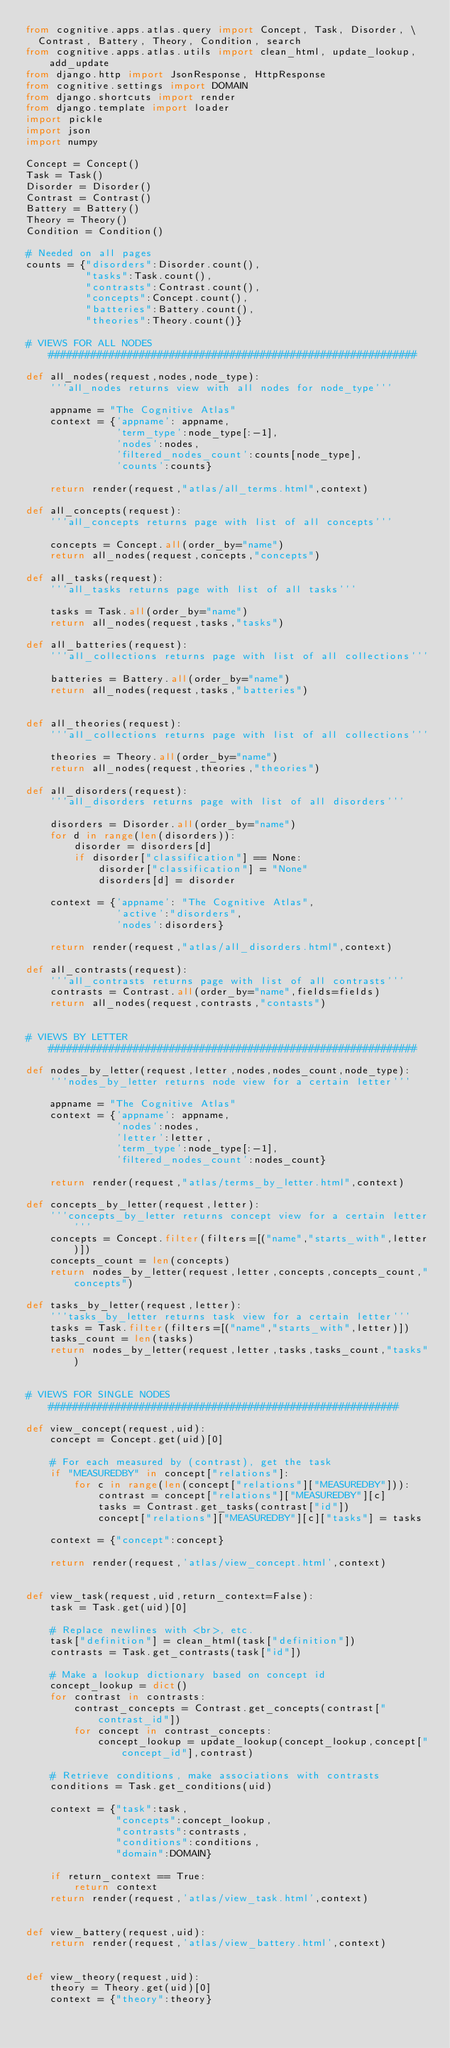Convert code to text. <code><loc_0><loc_0><loc_500><loc_500><_Python_>from cognitive.apps.atlas.query import Concept, Task, Disorder, \
  Contrast, Battery, Theory, Condition, search
from cognitive.apps.atlas.utils import clean_html, update_lookup, add_update
from django.http import JsonResponse, HttpResponse
from cognitive.settings import DOMAIN
from django.shortcuts import render
from django.template import loader
import pickle
import json
import numpy

Concept = Concept()
Task = Task()
Disorder = Disorder()
Contrast = Contrast()
Battery = Battery()
Theory = Theory()
Condition = Condition()

# Needed on all pages
counts = {"disorders":Disorder.count(),
          "tasks":Task.count(),
          "contrasts":Contrast.count(),
          "concepts":Concept.count(),
          "batteries":Battery.count(),
          "theories":Theory.count()}

# VIEWS FOR ALL NODES #############################################################

def all_nodes(request,nodes,node_type):
    '''all_nodes returns view with all nodes for node_type'''

    appname = "The Cognitive Atlas"
    context = {'appname': appname,
               'term_type':node_type[:-1],
               'nodes':nodes,
               'filtered_nodes_count':counts[node_type],
               'counts':counts}

    return render(request,"atlas/all_terms.html",context)

def all_concepts(request):
    '''all_concepts returns page with list of all concepts'''

    concepts = Concept.all(order_by="name")
    return all_nodes(request,concepts,"concepts")
    
def all_tasks(request):
    '''all_tasks returns page with list of all tasks'''

    tasks = Task.all(order_by="name")
    return all_nodes(request,tasks,"tasks")    

def all_batteries(request):
    '''all_collections returns page with list of all collections'''

    batteries = Battery.all(order_by="name")
    return all_nodes(request,tasks,"batteries")    


def all_theories(request):
    '''all_collections returns page with list of all collections'''

    theories = Theory.all(order_by="name")
    return all_nodes(request,theories,"theories")    

def all_disorders(request):
    '''all_disorders returns page with list of all disorders'''

    disorders = Disorder.all(order_by="name")    
    for d in range(len(disorders)):
        disorder = disorders[d]
        if disorder["classification"] == None:
            disorder["classification"] = "None"
            disorders[d] = disorder

    context = {'appname': "The Cognitive Atlas",
               'active':"disorders",
               'nodes':disorders}

    return render(request,"atlas/all_disorders.html",context)

def all_contrasts(request):
    '''all_contrasts returns page with list of all contrasts'''
    contrasts = Contrast.all(order_by="name",fields=fields)
    return all_nodes(request,contrasts,"contasts")    


# VIEWS BY LETTER #############################################################

def nodes_by_letter(request,letter,nodes,nodes_count,node_type):
    '''nodes_by_letter returns node view for a certain letter'''

    appname = "The Cognitive Atlas"
    context = {'appname': appname,
               'nodes':nodes,
               'letter':letter,
               'term_type':node_type[:-1],
               'filtered_nodes_count':nodes_count}

    return render(request,"atlas/terms_by_letter.html",context)

def concepts_by_letter(request,letter):
    '''concepts_by_letter returns concept view for a certain letter'''
    concepts = Concept.filter(filters=[("name","starts_with",letter)])
    concepts_count = len(concepts)
    return nodes_by_letter(request,letter,concepts,concepts_count,"concepts")

def tasks_by_letter(request,letter):
    '''tasks_by_letter returns task view for a certain letter'''
    tasks = Task.filter(filters=[("name","starts_with",letter)])
    tasks_count = len(tasks)
    return nodes_by_letter(request,letter,tasks,tasks_count,"tasks")


# VIEWS FOR SINGLE NODES ##########################################################

def view_concept(request,uid):
    concept = Concept.get(uid)[0]

    # For each measured by (contrast), get the task
    if "MEASUREDBY" in concept["relations"]:
        for c in range(len(concept["relations"]["MEASUREDBY"])):
            contrast = concept["relations"]["MEASUREDBY"][c]
            tasks = Contrast.get_tasks(contrast["id"])
            concept["relations"]["MEASUREDBY"][c]["tasks"] = tasks

    context = {"concept":concept}

    return render(request,'atlas/view_concept.html',context)


def view_task(request,uid,return_context=False):
    task = Task.get(uid)[0]
 
    # Replace newlines with <br>, etc.
    task["definition"] = clean_html(task["definition"])
    contrasts = Task.get_contrasts(task["id"])

    # Make a lookup dictionary based on concept id
    concept_lookup = dict()
    for contrast in contrasts:
        contrast_concepts = Contrast.get_concepts(contrast["contrast_id"])
        for concept in contrast_concepts:
            concept_lookup = update_lookup(concept_lookup,concept["concept_id"],contrast)

    # Retrieve conditions, make associations with contrasts
    conditions = Task.get_conditions(uid)

    context = {"task":task,
               "concepts":concept_lookup,
               "contrasts":contrasts,
               "conditions":conditions,
               "domain":DOMAIN}

    if return_context == True:
        return context
    return render(request,'atlas/view_task.html',context)


def view_battery(request,uid):
    return render(request,'atlas/view_battery.html',context)


def view_theory(request,uid):
    theory = Theory.get(uid)[0]
    context = {"theory":theory}</code> 